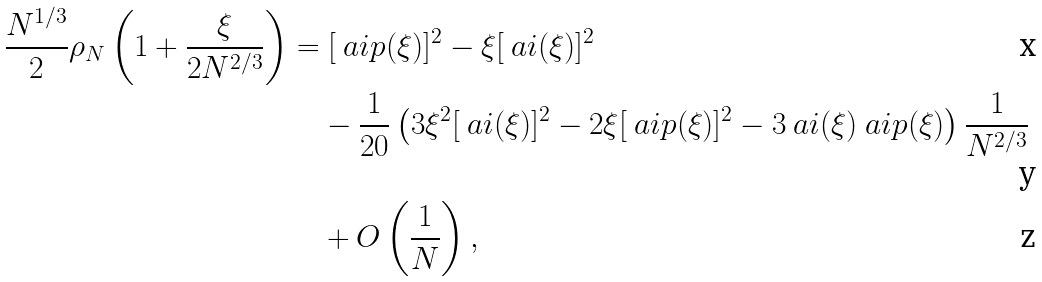Convert formula to latex. <formula><loc_0><loc_0><loc_500><loc_500>\frac { N ^ { 1 / 3 } } { 2 } \rho _ { N } \left ( 1 + \frac { \xi } { 2 N ^ { 2 / 3 } } \right ) & = [ \ a i p ( \xi ) ] ^ { 2 } - \xi [ \ a i ( \xi ) ] ^ { 2 } \\ & \quad - \frac { 1 } { 2 0 } \left ( 3 \xi ^ { 2 } [ \ a i ( \xi ) ] ^ { 2 } - 2 \xi [ \ a i p ( \xi ) ] ^ { 2 } - 3 \ a i ( \xi ) \ a i p ( \xi ) \right ) \frac { 1 } { N ^ { 2 / 3 } } \\ & \quad + O \left ( \frac { 1 } { N } \right ) ,</formula> 